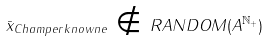<formula> <loc_0><loc_0><loc_500><loc_500>\bar { x } _ { C h a m p e r k n o w n e } \, \notin \, R A N D O M ( A ^ { \mathbb { N } _ { + } } )</formula> 